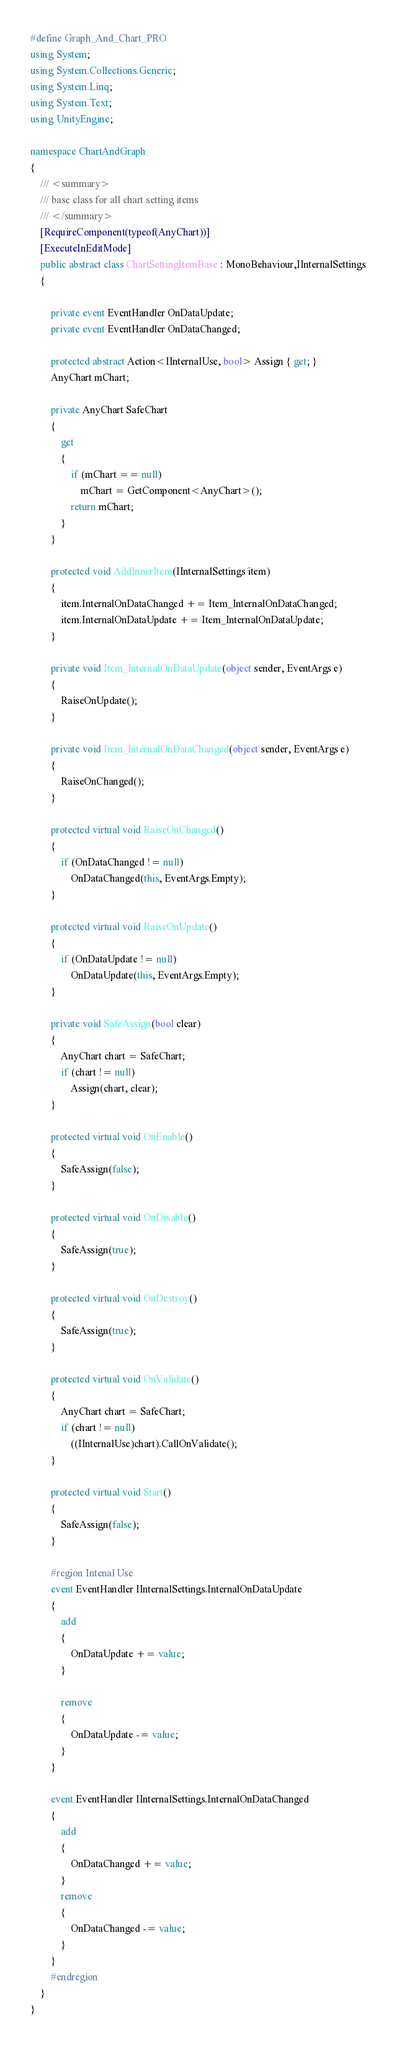Convert code to text. <code><loc_0><loc_0><loc_500><loc_500><_C#_>#define Graph_And_Chart_PRO
using System;
using System.Collections.Generic;
using System.Linq;
using System.Text;
using UnityEngine;

namespace ChartAndGraph
{
    /// <summary>
    /// base class for all chart setting items
    /// </summary>
    [RequireComponent(typeof(AnyChart))]
    [ExecuteInEditMode]
    public abstract class ChartSettingItemBase : MonoBehaviour,IInternalSettings
    {

        private event EventHandler OnDataUpdate;
        private event EventHandler OnDataChanged;

        protected abstract Action<IInternalUse, bool> Assign { get; }
        AnyChart mChart;

        private AnyChart SafeChart
        {
            get
            {
                if (mChart == null)
                    mChart = GetComponent<AnyChart>();
                return mChart;
            }
        }

        protected void AddInnerItem(IInternalSettings item)
        {
            item.InternalOnDataChanged += Item_InternalOnDataChanged;
            item.InternalOnDataUpdate += Item_InternalOnDataUpdate;
        }

        private void Item_InternalOnDataUpdate(object sender, EventArgs e)
        {
            RaiseOnUpdate();
        }

        private void Item_InternalOnDataChanged(object sender, EventArgs e)
        {
            RaiseOnChanged();
        }

        protected virtual void RaiseOnChanged()
        {
            if (OnDataChanged != null)
                OnDataChanged(this, EventArgs.Empty);
        }

        protected virtual void RaiseOnUpdate()
        {
            if (OnDataUpdate != null)
                OnDataUpdate(this, EventArgs.Empty);
        }

        private void SafeAssign(bool clear)
        {
            AnyChart chart = SafeChart;
            if (chart != null)
                Assign(chart, clear);
        }

        protected virtual void OnEnable()
        {
            SafeAssign(false);
        }

        protected virtual void OnDisable()
        {
            SafeAssign(true);
        }

        protected virtual void OnDestroy()
        {
            SafeAssign(true);
        }

        protected virtual void OnValidate()
        {
            AnyChart chart = SafeChart;
            if (chart != null)
                ((IInternalUse)chart).CallOnValidate();
        }

        protected virtual void Start()
        {
            SafeAssign(false);
        }

        #region Intenal Use
        event EventHandler IInternalSettings.InternalOnDataUpdate
        {
            add
            {
                OnDataUpdate += value;
            }

            remove
            {
                OnDataUpdate -= value;
            }
        }

        event EventHandler IInternalSettings.InternalOnDataChanged
        {
            add
            {
                OnDataChanged += value;
            }
            remove
            {
                OnDataChanged -= value;
            }
        }
        #endregion
    }
}
</code> 